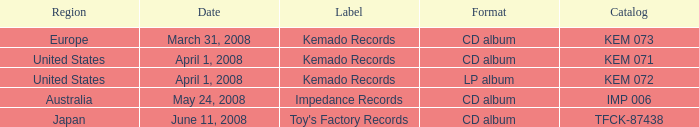Which Label has a Region of united states, and a Format of lp album? Kemado Records. 